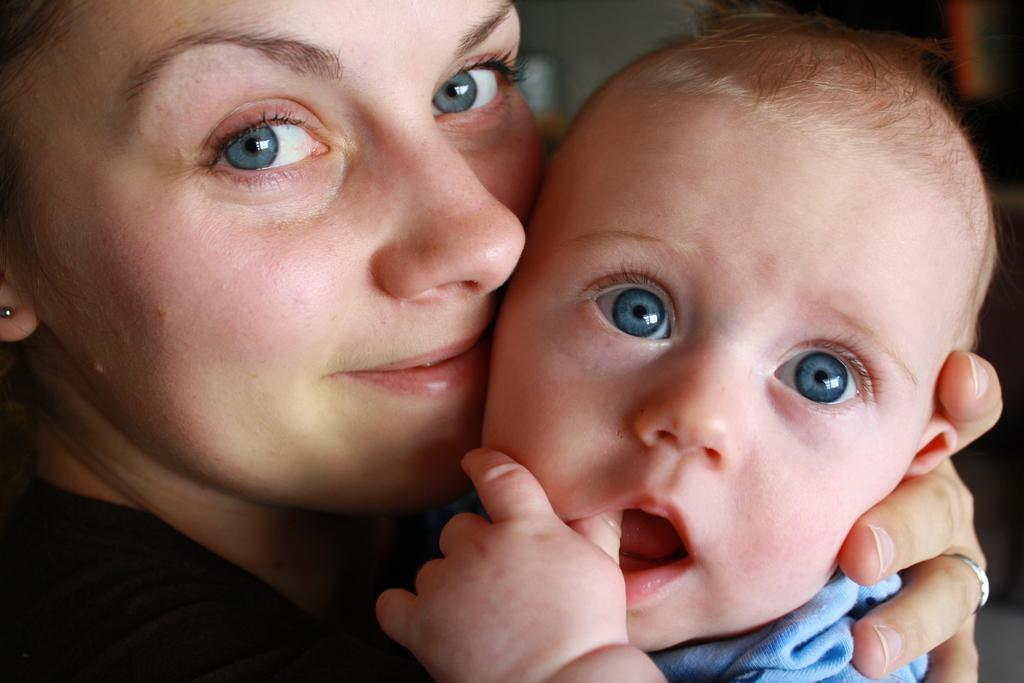Could you give a brief overview of what you see in this image? In this image I can see a lady holding baby. 